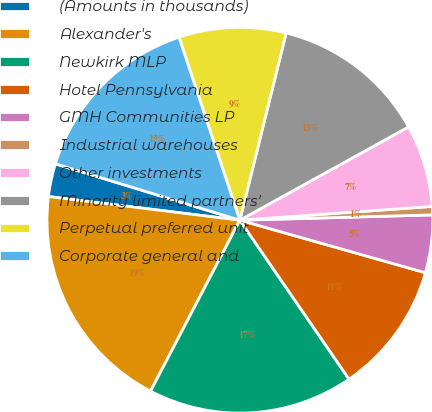<chart> <loc_0><loc_0><loc_500><loc_500><pie_chart><fcel>(Amounts in thousands)<fcel>Alexander's<fcel>Newkirk MLP<fcel>Hotel Pennsylvania<fcel>GMH Communities LP<fcel>Industrial warehouses<fcel>Other investments<fcel>Minority limited partners'<fcel>Perpetual preferred unit<fcel>Corporate general and<nl><fcel>2.76%<fcel>19.3%<fcel>17.24%<fcel>11.03%<fcel>4.83%<fcel>0.7%<fcel>6.9%<fcel>13.1%<fcel>8.97%<fcel>15.17%<nl></chart> 